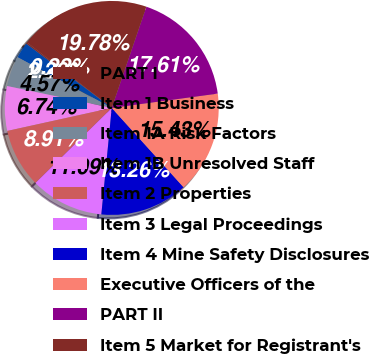<chart> <loc_0><loc_0><loc_500><loc_500><pie_chart><fcel>PART I<fcel>Item 1 Business<fcel>Item 1A Risk Factors<fcel>Item 1B Unresolved Staff<fcel>Item 2 Properties<fcel>Item 3 Legal Proceedings<fcel>Item 4 Mine Safety Disclosures<fcel>Executive Officers of the<fcel>PART II<fcel>Item 5 Market for Registrant's<nl><fcel>0.22%<fcel>2.39%<fcel>4.57%<fcel>6.74%<fcel>8.91%<fcel>11.09%<fcel>13.26%<fcel>15.43%<fcel>17.61%<fcel>19.78%<nl></chart> 